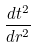<formula> <loc_0><loc_0><loc_500><loc_500>\frac { d t ^ { 2 } } { d r ^ { 2 } }</formula> 